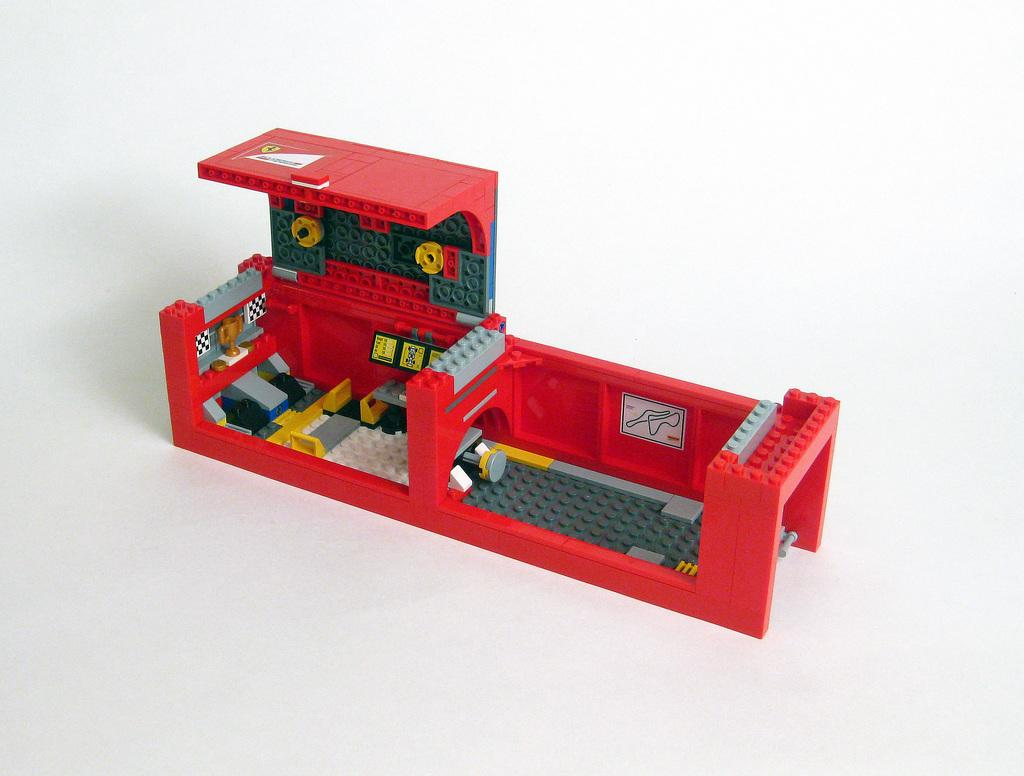What type of toy is in the image? There is a Lego toy in the image. What is the color of the surface the Lego toy is on? The Lego toy is on a white surface. What colors can be seen on the Lego toy? The colors of the Lego toy include red, green, yellow, and grey. What type of secretary is present in the image? There is no secretary present in the image; it features a Lego toy on a white surface. How does the wind affect the Lego toy in the image? The image does not depict any wind or its effects on the Lego toy, as it is a still image. 